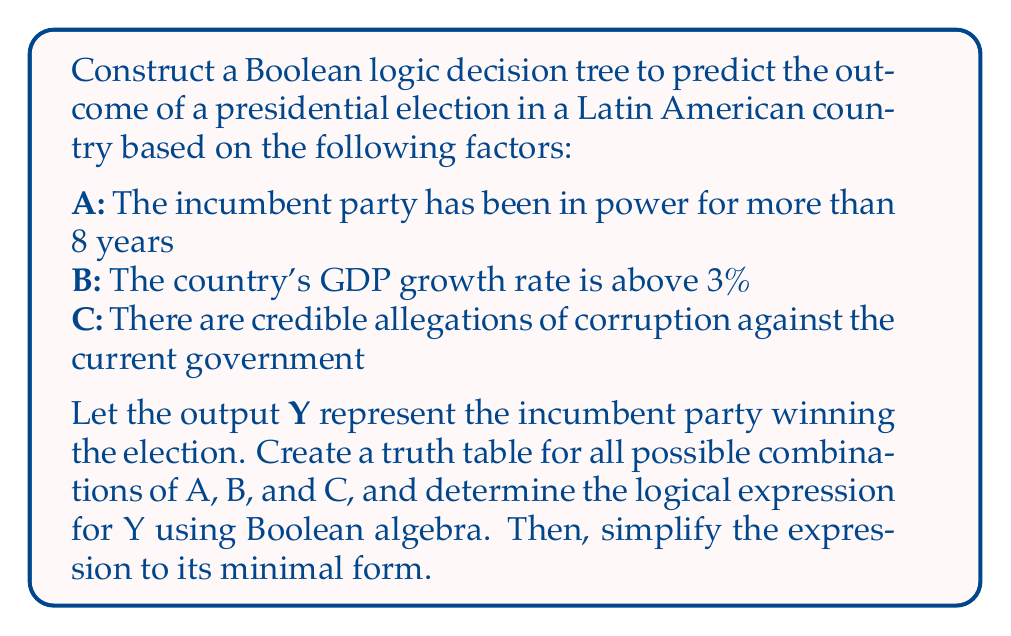Can you solve this math problem? Step 1: Create a truth table for all possible combinations of A, B, and C.

$$
\begin{array}{|c|c|c|c|}
\hline
A & B & C & Y \\
\hline
0 & 0 & 0 & 1 \\
0 & 0 & 1 & 0 \\
0 & 1 & 0 & 1 \\
0 & 1 & 1 & 0 \\
1 & 0 & 0 & 0 \\
1 & 0 & 1 & 0 \\
1 & 1 & 0 & 1 \\
1 & 1 & 1 & 0 \\
\hline
\end{array}
$$

Step 2: Write the logical expression for Y using the sum of products method.

$Y = \overline{A}\cdot\overline{B}\cdot\overline{C} + \overline{A}\cdot B\cdot\overline{C} + A\cdot B\cdot\overline{C}$

Step 3: Simplify the expression using Boolean algebra laws.

$Y = \overline{A}\cdot\overline{B}\cdot\overline{C} + \overline{A}\cdot B\cdot\overline{C} + A\cdot B\cdot\overline{C}$
$= (\overline{A}\cdot\overline{B} + \overline{A}\cdot B + A\cdot B)\cdot\overline{C}$
$= (\overline{A}(\overline{B} + B) + A\cdot B)\cdot\overline{C}$
$= (\overline{A} + A\cdot B)\cdot\overline{C}$

Step 4: Apply the absorption law: $\overline{A} + A\cdot B = \overline{A} + B$

$Y = (\overline{A} + B)\cdot\overline{C}$

This is the minimal form of the Boolean expression.
Answer: $Y = (\overline{A} + B)\cdot\overline{C}$ 